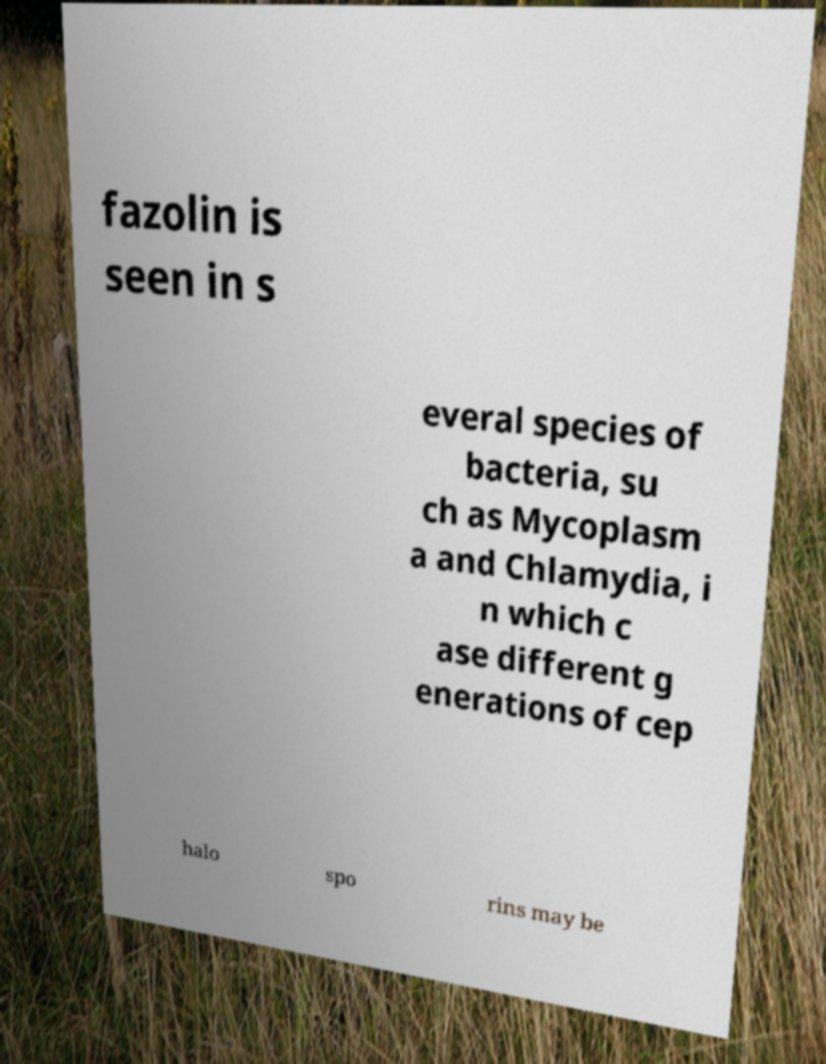Please read and relay the text visible in this image. What does it say? fazolin is seen in s everal species of bacteria, su ch as Mycoplasm a and Chlamydia, i n which c ase different g enerations of cep halo spo rins may be 